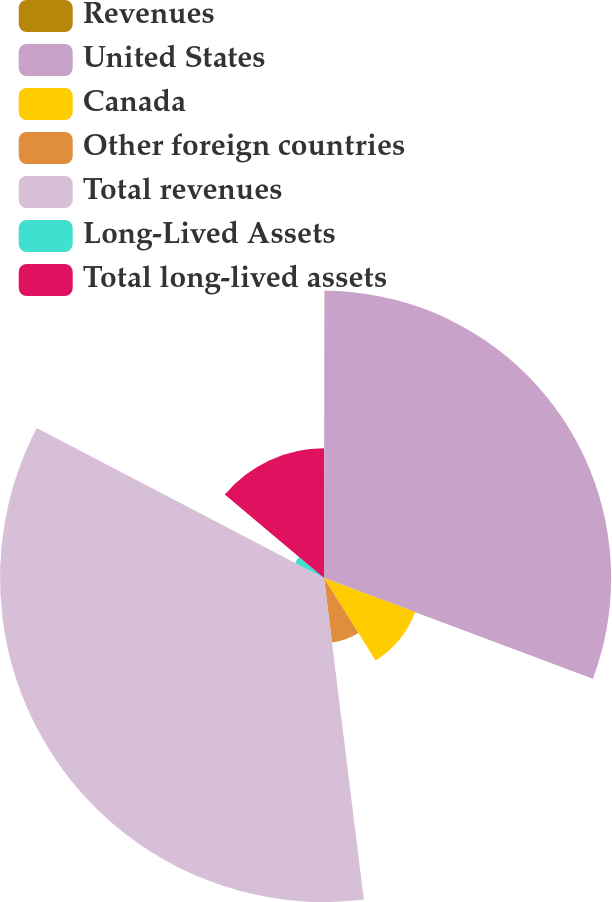<chart> <loc_0><loc_0><loc_500><loc_500><pie_chart><fcel>Revenues<fcel>United States<fcel>Canada<fcel>Other foreign countries<fcel>Total revenues<fcel>Long-Lived Assets<fcel>Total long-lived assets<nl><fcel>0.02%<fcel>30.68%<fcel>10.4%<fcel>6.94%<fcel>34.62%<fcel>3.48%<fcel>13.86%<nl></chart> 